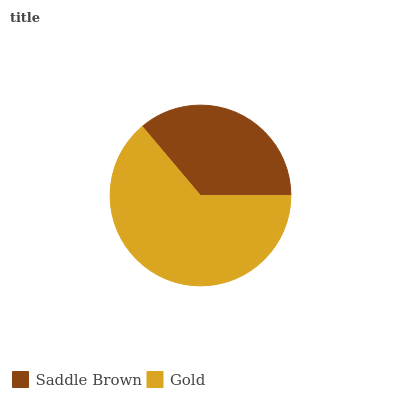Is Saddle Brown the minimum?
Answer yes or no. Yes. Is Gold the maximum?
Answer yes or no. Yes. Is Gold the minimum?
Answer yes or no. No. Is Gold greater than Saddle Brown?
Answer yes or no. Yes. Is Saddle Brown less than Gold?
Answer yes or no. Yes. Is Saddle Brown greater than Gold?
Answer yes or no. No. Is Gold less than Saddle Brown?
Answer yes or no. No. Is Gold the high median?
Answer yes or no. Yes. Is Saddle Brown the low median?
Answer yes or no. Yes. Is Saddle Brown the high median?
Answer yes or no. No. Is Gold the low median?
Answer yes or no. No. 